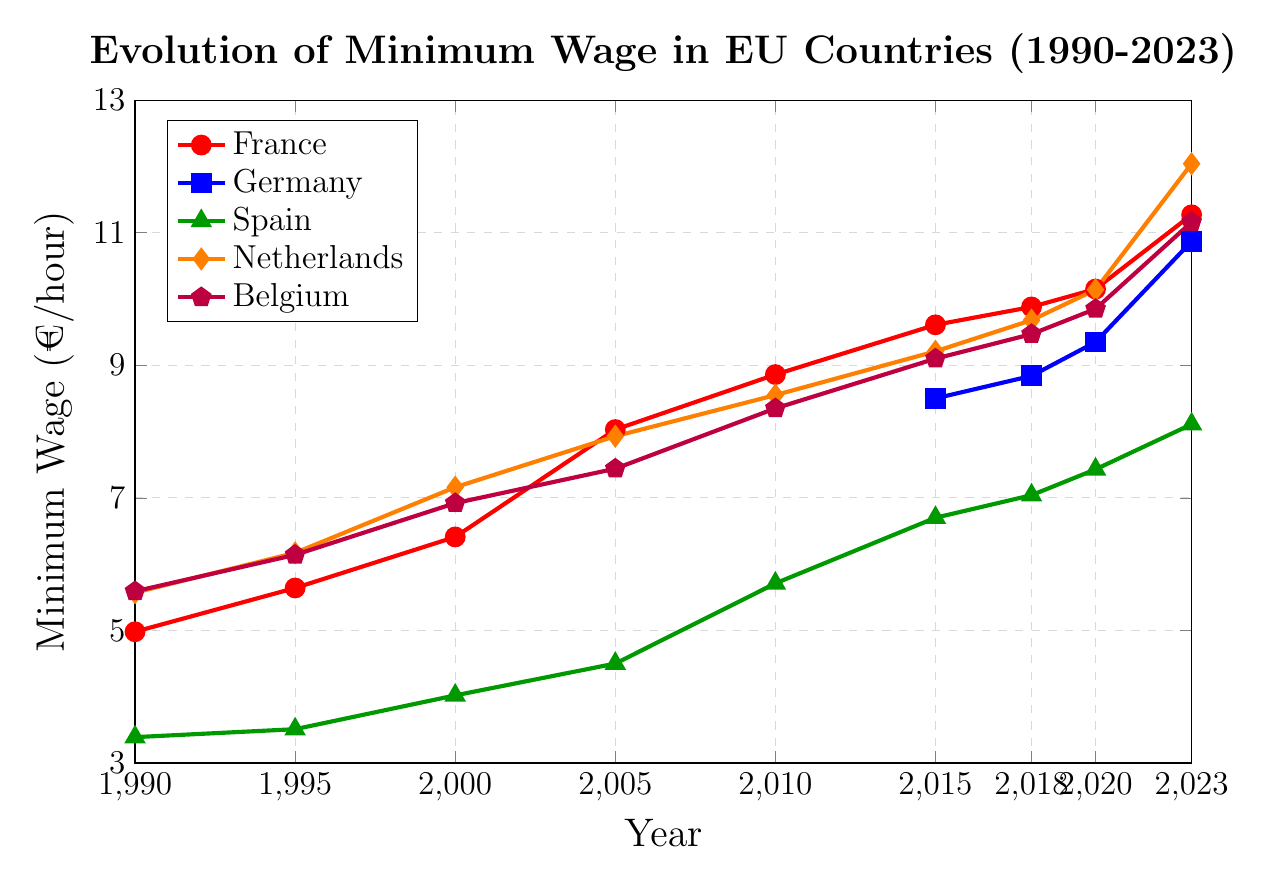What's the minimum wage in France in 2023? To answer this question, locate the data point for France in 2023 on the line chart. The value is given directly on the y-axis corresponding to the year 2023.
Answer: 11.27 Which country had the highest minimum wage in 2023? Compare the data points for all countries on the line chart for the year 2023. Identify the country with the highest value on the y-axis.
Answer: Netherlands Between 1990 and 2023, which country showed the greatest overall increase in minimum wage, and by how much? To determine this, calculate the difference between the minimum wage values in 2023 and 1990 for each country. Then, compare these differences to find the greatest one.
Answer: Netherlands, 6.47 (12.04 - 5.57) How does the minimum wage in France in 2015 compare to Germany in the same year? Locate the data points for both France and Germany in 2015 on the line chart and compare their values.
Answer: France had a higher minimum wage (France: 9.61, Germany: 8.50) What is the trend in minimum wage for Spain from 1990 to 2023? Analyze the line representing Spain from 1990 to 2023. Observe whether the values are increasing, decreasing, or remaining constant over the years.
Answer: Increasing Calculate the average minimum wage in France from 1990 to 2023. Sum all the minimum wage values for France provided on the line chart and then divide by the number of data points (9 years: 1990, 1995, 2000, 2005, 2010, 2015, 2018, 2020, 2023).
Answer: 8.64 Which country had a minimum wage of 5.71 €/hour in 2010? Check the data points on the line chart for the year 2010 and identify the country with a minimum wage of 5.71 €/hour.
Answer: Spain Identify the years and corresponding minimum wages for Germany from the data provided. Germany's minimum wage data starts from 2015. List the minimum wages for the years 2015, 2018, 2020, and 2023.
Answer: 2015: 8.50, 2018: 8.84, 2020: 9.35, 2023: 10.87 Compare the minimum wage trends of Netherlands and Belgium from 1990 to 2023. Observe the lines representing the Netherlands and Belgium on the chart. Note how both lines progress over the years and compare their increasing rates and overall shapes.
Answer: Both increasing; Netherlands shows a steeper increase compared to Belgium 